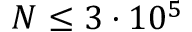<formula> <loc_0><loc_0><loc_500><loc_500>N \leq 3 \cdot 1 0 ^ { 5 }</formula> 